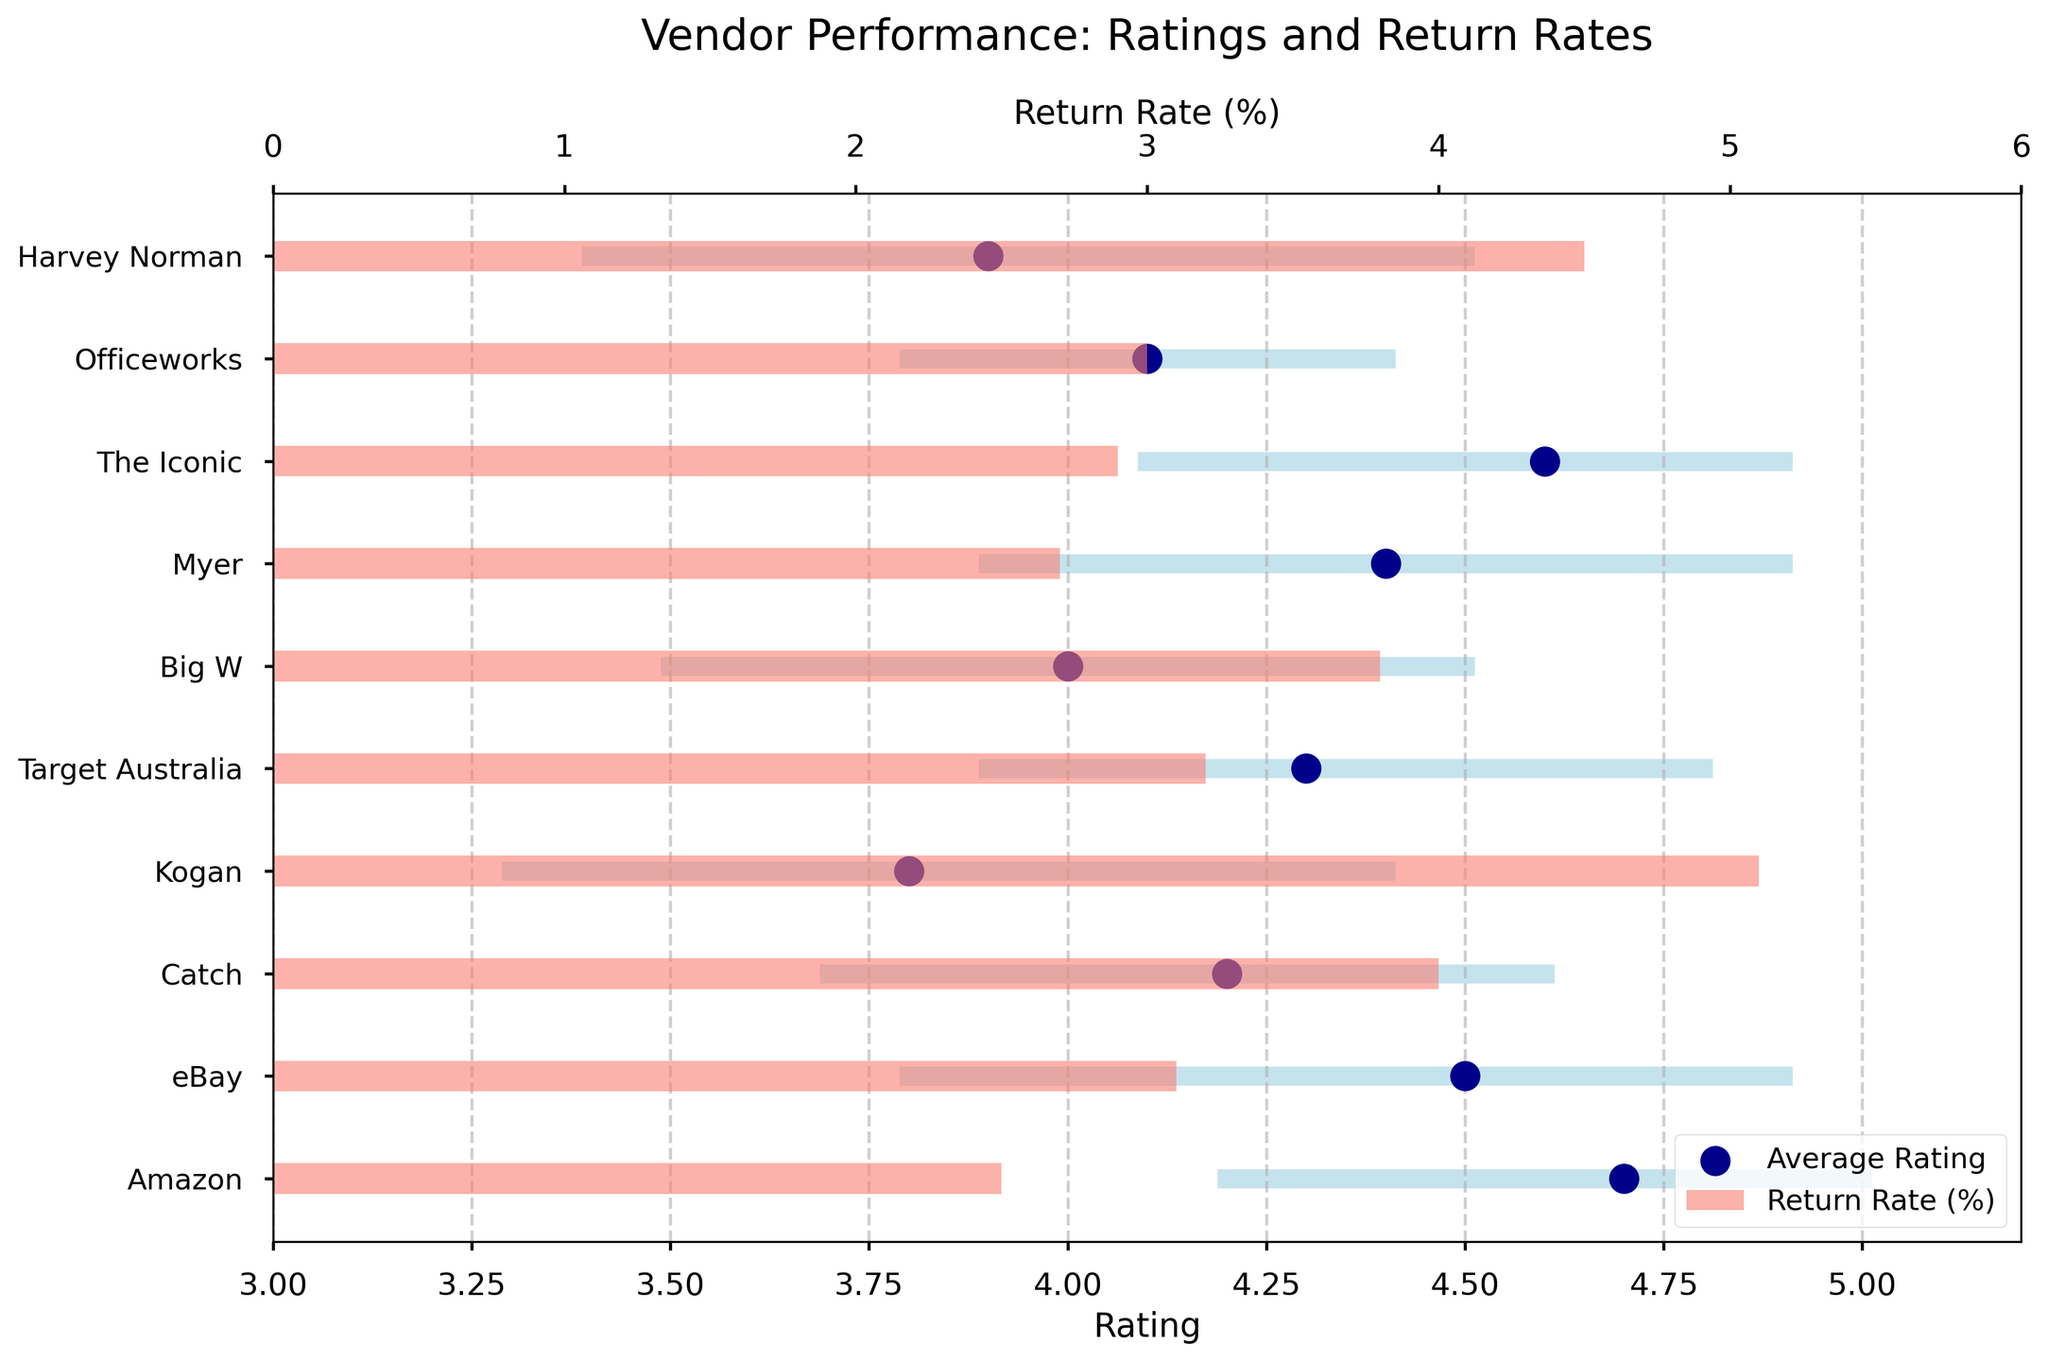How many vendors have an average rating of 4.0 or higher? Look at the 'Average Rating' column on the x-axis and count the dots that are at 4.0 or above. The vendors with 4.0 or higher are Amazon, eBay, Catch, Target Australia, Myer, The Iconic, and Officeworks.
Answer: 7 What is the vendor with the lowest return rate? Look at the bar lengths representing the return rates on the upper x-axis. The shortest return rate bar corresponds to Amazon.
Answer: Amazon Which vendor has the widest range in ratings? Look at the horizontal lines that represent the rating ranges and find the longest one. Kogan has the widest range, from 3.3 to 4.4.
Answer: Kogan Compare the average ratings of eBay and Myer. Which one is higher? Find the locations of eBay and Myer on the y-axis and compare their positions on the x-axis. Myer's average rating (4.4) is slightly higher than eBay's average rating (4.5).
Answer: Myer Which vendor has the smallest difference between the highest and lowest rating within its range? Calculate the differences between the highest and lowest ratings for each vendor. The smallest difference is between 4.2 and 5.0 for Amazon.
Answer: Amazon What is the average return rate for vendors with an average rating above 4.5? Identify the vendors with ratings above 4.5: Amazon and The Iconic. Their return rates are 2.5% and 2.9%. The average is (2.5 + 2.9)/2 = 2.7%.
Answer: 2.7% Which vendor has a higher return rate: Catch or Harvey Norman? Compare the bar lengths for Catch and Harvey Norman on the upper x-axis. Harvey Norman's return rate (4.5%) is higher than Catch's return rate (4.0%).
Answer: Harvey Norman What is the range of ratings for Big W? Find Big W on the y-axis and refer to its horizontal line. The range is from 3.5 to 4.5.
Answer: 3.5-4.5 Based on the dot plot, which vendors have a narrower rating range than Big W? Check the horizontal lines against Big W's range (3.5 to 4.5). Amazon, eBay, Myer, The Iconic, Officeworks, and Target Australia have narrower ranges.
Answer: Amazon, eBay, Myer, The Iconic, Officeworks, Target Australia Compare the average ratings and return rates of Kogan and Harvey Norman. Which vendor performs better overall? Check the positions of Kogan and Harvey Norman on both the x-axes for ratings and return rates. Kogan's average rating (3.8) is less than Harvey Norman's (3.9), and Kogan's return rate (5.1%) is higher than Harvey Norman's return rate (4.5%).
Answer: Harvey Norman 